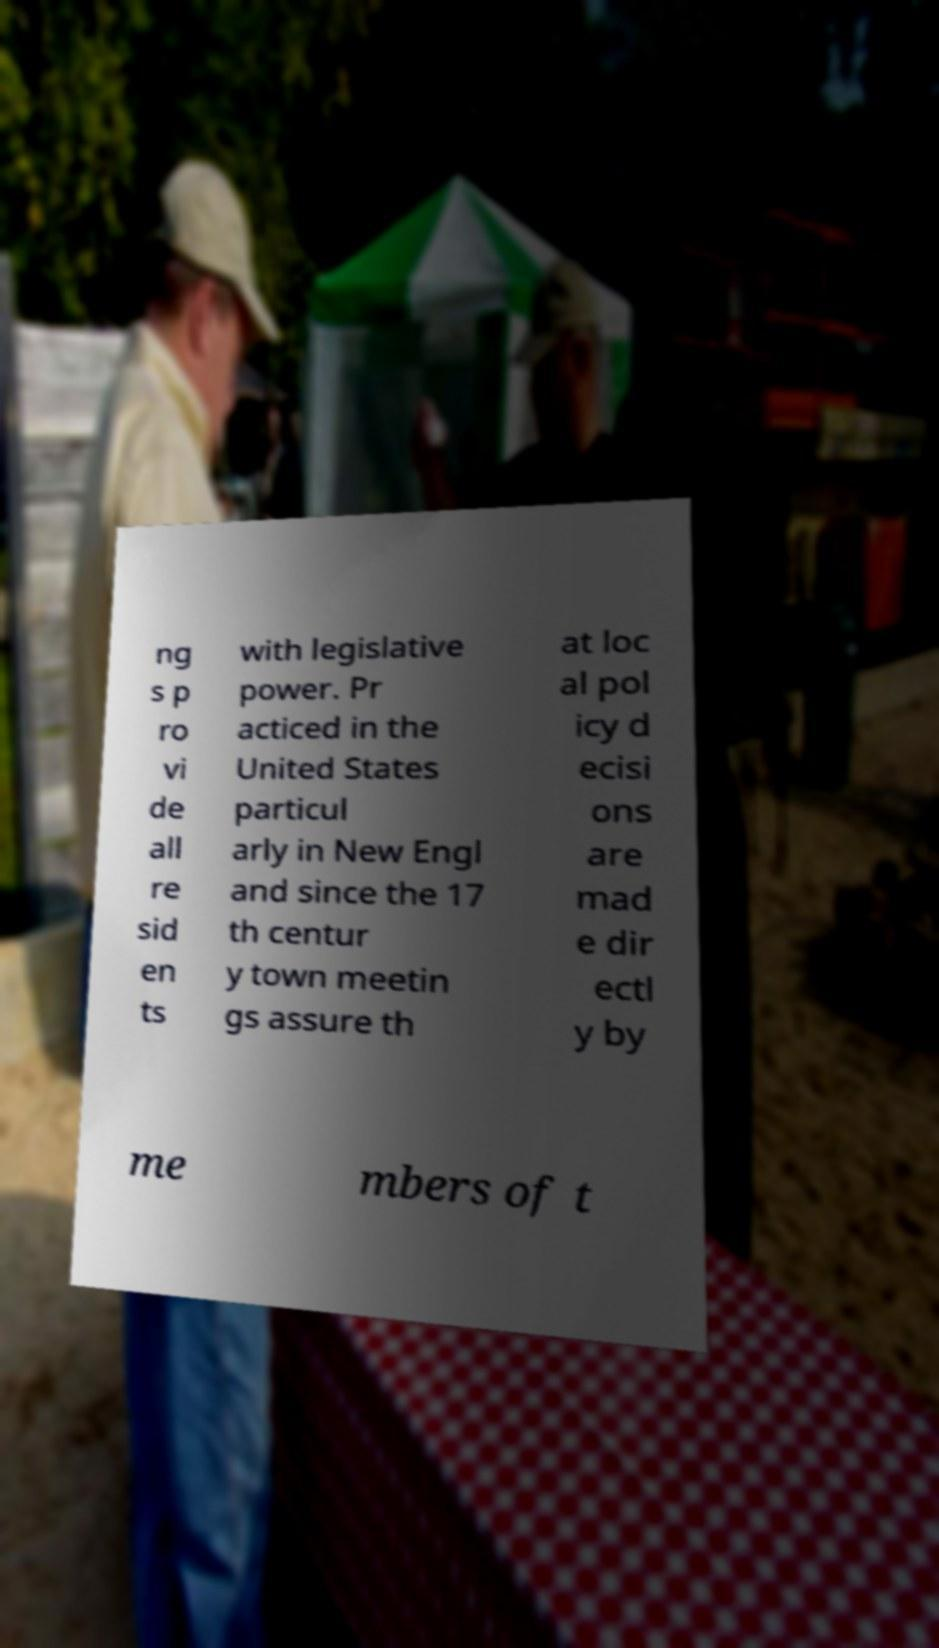Please identify and transcribe the text found in this image. ng s p ro vi de all re sid en ts with legislative power. Pr acticed in the United States particul arly in New Engl and since the 17 th centur y town meetin gs assure th at loc al pol icy d ecisi ons are mad e dir ectl y by me mbers of t 